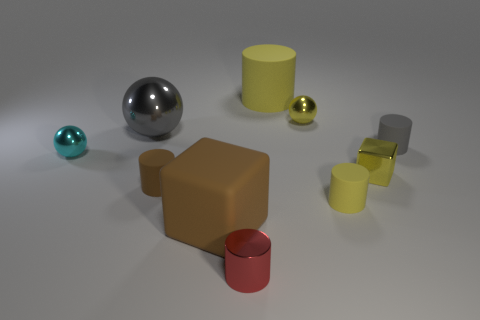Subtract all gray blocks. Subtract all cyan cylinders. How many blocks are left? 2 Subtract all gray blocks. How many red cylinders are left? 1 Add 1 purples. How many grays exist? 0 Subtract all big yellow rubber cylinders. Subtract all big matte blocks. How many objects are left? 8 Add 7 small rubber cylinders. How many small rubber cylinders are left? 10 Add 2 cubes. How many cubes exist? 4 Subtract all red cylinders. How many cylinders are left? 4 Subtract all cyan metal balls. How many balls are left? 2 Subtract 0 purple blocks. How many objects are left? 10 Subtract all spheres. How many objects are left? 7 